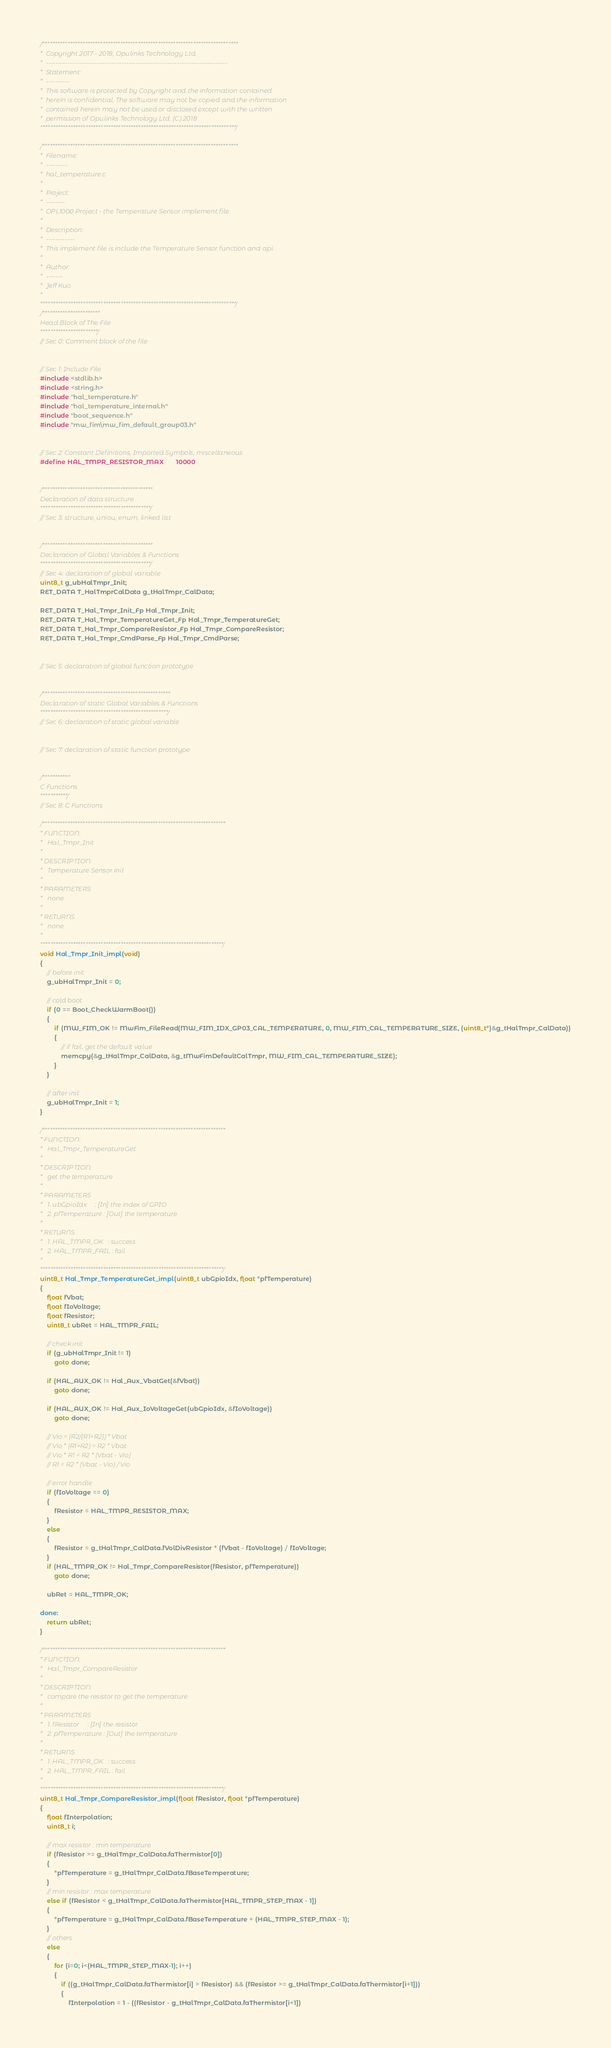Convert code to text. <code><loc_0><loc_0><loc_500><loc_500><_C_>/******************************************************************************
*  Copyright 2017 - 2018, Opulinks Technology Ltd.
*  ---------------------------------------------------------------------------
*  Statement:
*  ----------
*  This software is protected by Copyright and the information contained
*  herein is confidential. The software may not be copied and the information
*  contained herein may not be used or disclosed except with the written
*  permission of Opulinks Technology Ltd. (C) 2018
******************************************************************************/

/******************************************************************************
*  Filename:
*  ---------
*  hal_temperature.c
*
*  Project:
*  --------
*  OPL1000 Project - the Temperature Sensor implement file
*
*  Description:
*  ------------
*  This implement file is include the Temperature Sensor function and api.
*
*  Author:
*  -------
*  Jeff Kuo
*
******************************************************************************/
/***********************
Head Block of The File
***********************/
// Sec 0: Comment block of the file


// Sec 1: Include File
#include <stdlib.h>
#include <string.h>
#include "hal_temperature.h"
#include "hal_temperature_internal.h"
#include "boot_sequence.h"
#include "mw_fim\mw_fim_default_group03.h"


// Sec 2: Constant Definitions, Imported Symbols, miscellaneous
#define HAL_TMPR_RESISTOR_MAX       10000


/********************************************
Declaration of data structure
********************************************/
// Sec 3: structure, uniou, enum, linked list


/********************************************
Declaration of Global Variables & Functions
********************************************/
// Sec 4: declaration of global variable
uint8_t g_ubHalTmpr_Init;
RET_DATA T_HalTmprCalData g_tHalTmpr_CalData;

RET_DATA T_Hal_Tmpr_Init_Fp Hal_Tmpr_Init;
RET_DATA T_Hal_Tmpr_TemperatureGet_Fp Hal_Tmpr_TemperatureGet;
RET_DATA T_Hal_Tmpr_CompareResistor_Fp Hal_Tmpr_CompareResistor;
RET_DATA T_Hal_Tmpr_CmdParse_Fp Hal_Tmpr_CmdParse;


// Sec 5: declaration of global function prototype


/***************************************************
Declaration of static Global Variables & Functions
***************************************************/
// Sec 6: declaration of static global variable


// Sec 7: declaration of static function prototype


/***********
C Functions
***********/
// Sec 8: C Functions

/*************************************************************************
* FUNCTION:
*   Hal_Tmpr_Init
*
* DESCRIPTION:
*   Temperature Sensor init
*
* PARAMETERS
*   none
*
* RETURNS
*   none
*
*************************************************************************/
void Hal_Tmpr_Init_impl(void)
{
    // before init
    g_ubHalTmpr_Init = 0;

    // cold boot
    if (0 == Boot_CheckWarmBoot())
    {
        if (MW_FIM_OK != MwFim_FileRead(MW_FIM_IDX_GP03_CAL_TEMPERATURE, 0, MW_FIM_CAL_TEMPERATURE_SIZE, (uint8_t*)&g_tHalTmpr_CalData))
        {
            // if fail, get the default value
            memcpy(&g_tHalTmpr_CalData, &g_tMwFimDefaultCalTmpr, MW_FIM_CAL_TEMPERATURE_SIZE);
        }
    }

    // after init
    g_ubHalTmpr_Init = 1;
}

/*************************************************************************
* FUNCTION:
*   Hal_Tmpr_TemperatureGet
*
* DESCRIPTION:
*   get the temperature
*
* PARAMETERS
*   1. ubGpioIdx     : [In] the index of GPIO
*   2. pfTemperature : [Out] the temperature
*
* RETURNS
*   1. HAL_TMPR_OK   : success
*   2. HAL_TMPR_FAIL : fail
*
*************************************************************************/
uint8_t Hal_Tmpr_TemperatureGet_impl(uint8_t ubGpioIdx, float *pfTemperature)
{
    float fVbat;
    float fIoVoltage;
    float fResistor;
    uint8_t ubRet = HAL_TMPR_FAIL;
    
    // check init
    if (g_ubHalTmpr_Init != 1)
        goto done;

    if (HAL_AUX_OK != Hal_Aux_VbatGet(&fVbat))
        goto done;
    
    if (HAL_AUX_OK != Hal_Aux_IoVoltageGet(ubGpioIdx, &fIoVoltage))
        goto done;

    // Vio = (R2/(R1+R2)) * Vbat
    // Vio * (R1+R2) = R2 * Vbat
    // Vio * R1 = R2 * (Vbat - Vio)
    // R1 = R2 * (Vbat - Vio) / Vio

    // error handle
    if (fIoVoltage == 0)
    {
        fResistor = HAL_TMPR_RESISTOR_MAX;
    }
    else
    {
        fResistor = g_tHalTmpr_CalData.fVolDivResistor * (fVbat - fIoVoltage) / fIoVoltage;
    }
    if (HAL_TMPR_OK != Hal_Tmpr_CompareResistor(fResistor, pfTemperature))
        goto done;
    
    ubRet = HAL_TMPR_OK;

done:
    return ubRet;
}

/*************************************************************************
* FUNCTION:
*   Hal_Tmpr_CompareResistor
*
* DESCRIPTION:
*   compare the resistor to get the temperature
*
* PARAMETERS
*   1. fResistor     : [In] the resistor
*   2. pfTemperature : [Out] the temperature
*
* RETURNS
*   1. HAL_TMPR_OK   : success
*   2. HAL_TMPR_FAIL : fail
*
*************************************************************************/
uint8_t Hal_Tmpr_CompareResistor_impl(float fResistor, float *pfTemperature)
{
    float fInterpolation;
    uint8_t i;
    
    // max resistor : min temperature
    if (fResistor >= g_tHalTmpr_CalData.faThermistor[0])
    {
        *pfTemperature = g_tHalTmpr_CalData.fBaseTemperature;
    }
    // min resistor : max temperature
    else if (fResistor < g_tHalTmpr_CalData.faThermistor[HAL_TMPR_STEP_MAX - 1])
    {
        *pfTemperature = g_tHalTmpr_CalData.fBaseTemperature + (HAL_TMPR_STEP_MAX - 1);
    }
    // others
    else
    {
        for (i=0; i<(HAL_TMPR_STEP_MAX-1); i++)
        {
            if ((g_tHalTmpr_CalData.faThermistor[i] > fResistor) && (fResistor >= g_tHalTmpr_CalData.faThermistor[i+1]))
            {
                fInterpolation = 1 - ((fResistor - g_tHalTmpr_CalData.faThermistor[i+1])</code> 